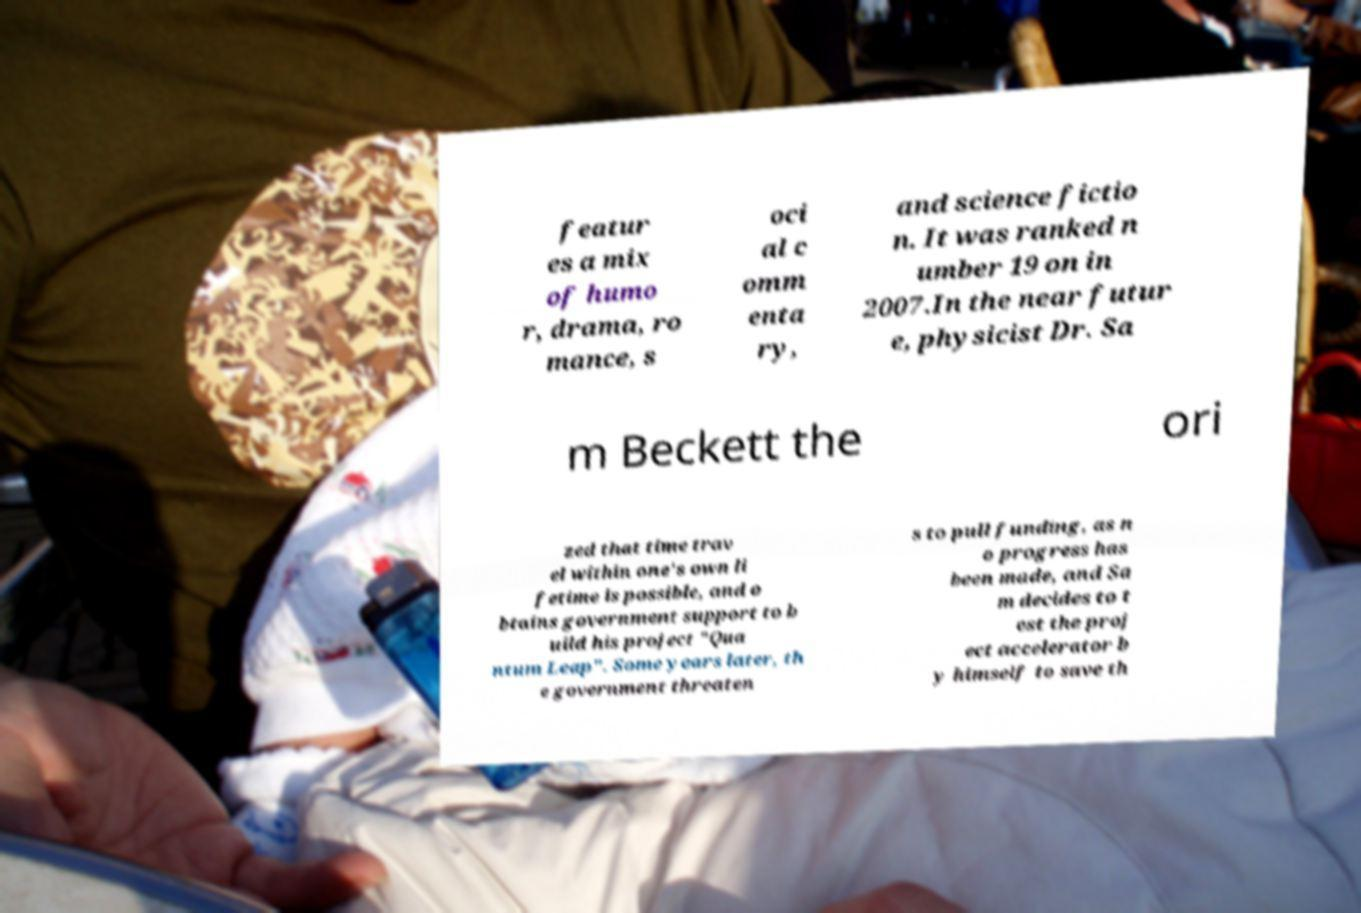Please read and relay the text visible in this image. What does it say? featur es a mix of humo r, drama, ro mance, s oci al c omm enta ry, and science fictio n. It was ranked n umber 19 on in 2007.In the near futur e, physicist Dr. Sa m Beckett the ori zed that time trav el within one's own li fetime is possible, and o btains government support to b uild his project "Qua ntum Leap". Some years later, th e government threaten s to pull funding, as n o progress has been made, and Sa m decides to t est the proj ect accelerator b y himself to save th 